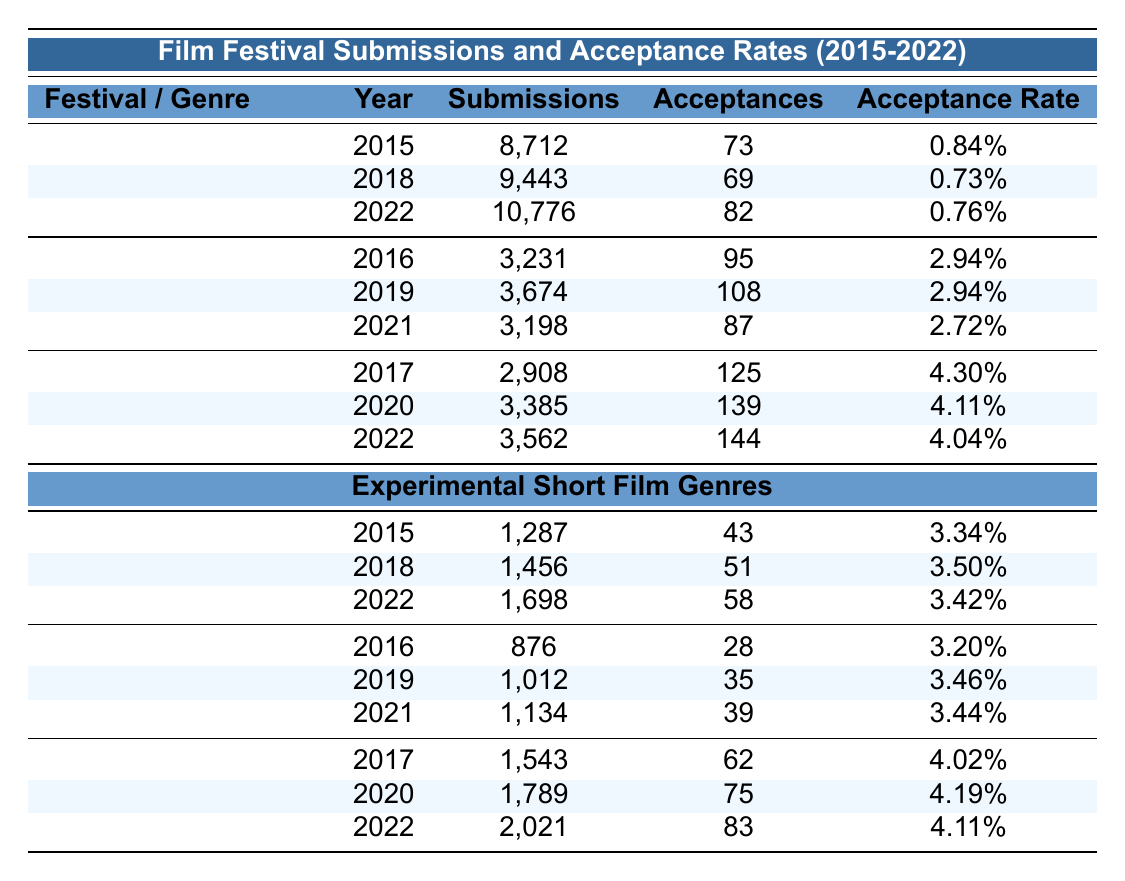What is the acceptance rate for the Ann Arbor Film Festival in 2022? The acceptance rate for the Ann Arbor Film Festival in 2022 is directly listed as 4.04%.
Answer: 4.04% How many total submissions were made to the Sundance Film Festival from 2015 to 2022? The total submissions are calculated by adding the submissions from each year: 8712 + 9443 + 10776 = 35931.
Answer: 35931 Which festival had the highest acceptance rate in 2017? The Ann Arbor Film Festival had an acceptance rate of 4.30% in 2017, which is higher than the rates of the other festivals listed.
Answer: 4.30% What was the average acceptance rate of experimental short films at the International Film Festival Rotterdam from 2016 to 2021? The acceptance rates are 2.94%, 2.94%, and 2.72% for the years 2016, 2019, and 2021. The average is (2.94 + 2.94 + 2.72) / 3 = 2.87333% which can be rounded to 2.87%.
Answer: 2.87% Did the Sundance Film Festival's acceptance rate improve from 2015 to 2022? The acceptance rates over the years were 0.84%, 0.73%, and 0.76%. Since the rates decreased from 2015 to 2018, then slightly increased in 2022, it cannot be concluded that it improved overall.
Answer: No What is the total number of acceptances for abstract films from 2015 to 2022? Adding the acceptances from each year: 43 (2015) + 51 (2018) + 58 (2022) = 152.
Answer: 152 Which genre had the highest acceptance rate in 2020? In 2020, the Non-narrative genre had an acceptance rate of 4.19%, which is higher than the rates of the other genres listed for the same year.
Answer: 4.19% Was there an increase in both submissions and acceptances for the Ann Arbor Film Festival from 2020 to 2022? The submissions increased from 3385 in 2020 to 3562 in 2022, and acceptances increased from 139 in 2020 to 144 in 2022. Therefore, both metrics increased.
Answer: Yes What is the percentage difference in acceptance rates between the Ann Arbor Film Festival in 2017 and the Sundance Film Festival in the same year? Ann Arbor's rate was 4.30% and Sundance's rate was 0.84%. The difference is 4.30 - 0.84 = 3.46%.
Answer: 3.46% Which festival had the least number of submissions in the year 2021? The International Film Festival Rotterdam had 3198 submissions in 2021, which is the least compared to the other festivals for the same year.
Answer: 3198 How many submissions did the Found Footage genre receive in total from 2016 to 2021? The submissions for Found Footage over the years were 876 (2016) + 1012 (2019) + 1134 (2021) = 3022.
Answer: 3022 